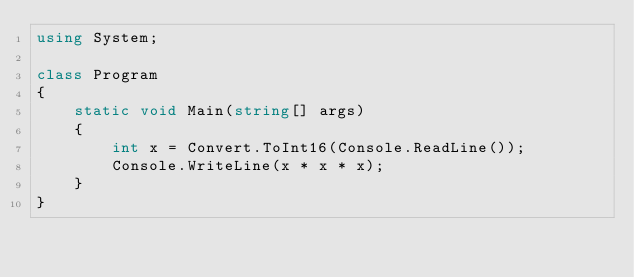Convert code to text. <code><loc_0><loc_0><loc_500><loc_500><_C#_>using System;

class Program
{
    static void Main(string[] args)
    {
        int x = Convert.ToInt16(Console.ReadLine());
        Console.WriteLine(x * x * x);
    }
}</code> 